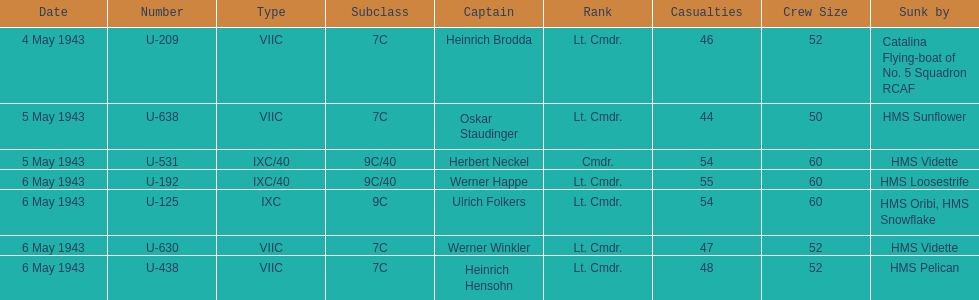Which date had at least 55 casualties? 6 May 1943. 